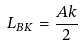<formula> <loc_0><loc_0><loc_500><loc_500>L _ { B K } = \frac { A k } { 2 }</formula> 